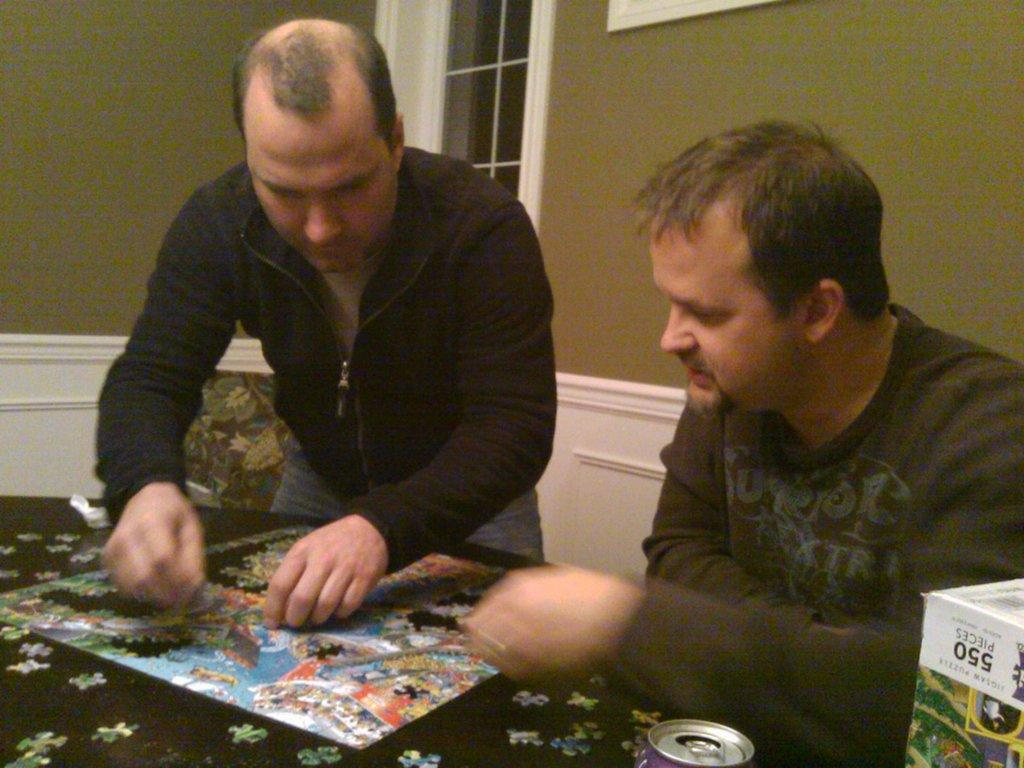How many people are in the image? There are two people in the image. What are the two people doing in the image? The two people are solving a puzzle. Where is the puzzle located in the image? The puzzle is on a table. What type of vegetable is being used as a tool to solve the puzzle in the image? There is no vegetable present in the image, and vegetables are not used as tools to solve puzzles. 